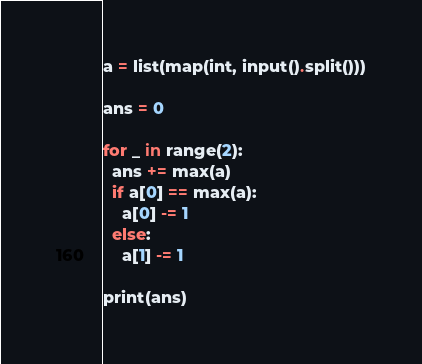Convert code to text. <code><loc_0><loc_0><loc_500><loc_500><_Python_>a = list(map(int, input().split()))

ans = 0

for _ in range(2):
  ans += max(a)
  if a[0] == max(a):
    a[0] -= 1
  else:
    a[1] -= 1

print(ans)</code> 